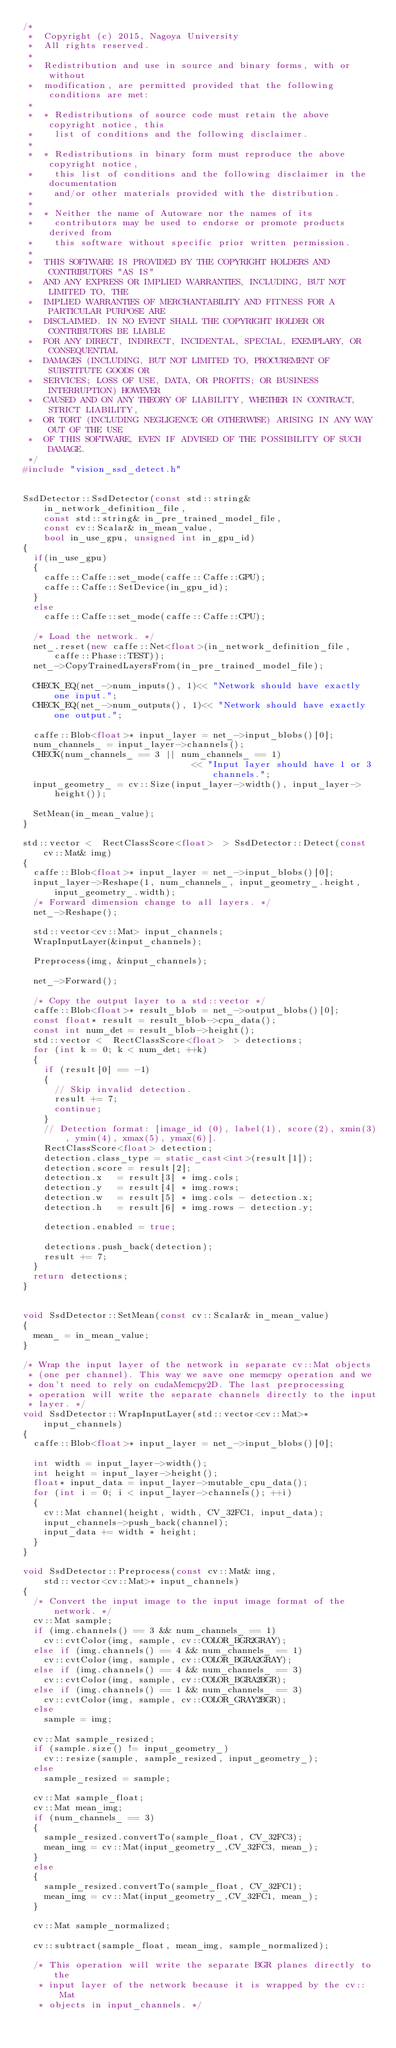<code> <loc_0><loc_0><loc_500><loc_500><_C++_>/*
 *  Copyright (c) 2015, Nagoya University
 *  All rights reserved.
 *
 *  Redistribution and use in source and binary forms, with or without
 *  modification, are permitted provided that the following conditions are met:
 *
 *  * Redistributions of source code must retain the above copyright notice, this
 *    list of conditions and the following disclaimer.
 *
 *  * Redistributions in binary form must reproduce the above copyright notice,
 *    this list of conditions and the following disclaimer in the documentation
 *    and/or other materials provided with the distribution.
 *
 *  * Neither the name of Autoware nor the names of its
 *    contributors may be used to endorse or promote products derived from
 *    this software without specific prior written permission.
 *
 *  THIS SOFTWARE IS PROVIDED BY THE COPYRIGHT HOLDERS AND CONTRIBUTORS "AS IS"
 *  AND ANY EXPRESS OR IMPLIED WARRANTIES, INCLUDING, BUT NOT LIMITED TO, THE
 *  IMPLIED WARRANTIES OF MERCHANTABILITY AND FITNESS FOR A PARTICULAR PURPOSE ARE
 *  DISCLAIMED. IN NO EVENT SHALL THE COPYRIGHT HOLDER OR CONTRIBUTORS BE LIABLE
 *  FOR ANY DIRECT, INDIRECT, INCIDENTAL, SPECIAL, EXEMPLARY, OR CONSEQUENTIAL
 *  DAMAGES (INCLUDING, BUT NOT LIMITED TO, PROCUREMENT OF SUBSTITUTE GOODS OR
 *  SERVICES; LOSS OF USE, DATA, OR PROFITS; OR BUSINESS INTERRUPTION) HOWEVER
 *  CAUSED AND ON ANY THEORY OF LIABILITY, WHETHER IN CONTRACT, STRICT LIABILITY,
 *  OR TORT (INCLUDING NEGLIGENCE OR OTHERWISE) ARISING IN ANY WAY OUT OF THE USE
 *  OF THIS SOFTWARE, EVEN IF ADVISED OF THE POSSIBILITY OF SUCH DAMAGE.
 */
#include "vision_ssd_detect.h"


SsdDetector::SsdDetector(const std::string& in_network_definition_file,
		const std::string& in_pre_trained_model_file,
		const cv::Scalar& in_mean_value,
		bool in_use_gpu, unsigned int in_gpu_id)
{
	if(in_use_gpu)
	{
		caffe::Caffe::set_mode(caffe::Caffe::GPU);
		caffe::Caffe::SetDevice(in_gpu_id);
	}
	else
		caffe::Caffe::set_mode(caffe::Caffe::CPU);

	/* Load the network. */
	net_.reset(new caffe::Net<float>(in_network_definition_file, caffe::Phase::TEST));
	net_->CopyTrainedLayersFrom(in_pre_trained_model_file);

	CHECK_EQ(net_->num_inputs(), 1)<< "Network should have exactly one input.";
	CHECK_EQ(net_->num_outputs(), 1)<< "Network should have exactly one output.";

	caffe::Blob<float>* input_layer = net_->input_blobs()[0];
	num_channels_ = input_layer->channels();
	CHECK(num_channels_ == 3 || num_channels_ == 1)
																<< "Input layer should have 1 or 3 channels.";
	input_geometry_ = cv::Size(input_layer->width(), input_layer->height());

	SetMean(in_mean_value);
}

std::vector <  RectClassScore<float>  > SsdDetector::Detect(const cv::Mat& img)
{
	caffe::Blob<float>* input_layer = net_->input_blobs()[0];
	input_layer->Reshape(1, num_channels_, input_geometry_.height,
			input_geometry_.width);
	/* Forward dimension change to all layers. */
	net_->Reshape();

	std::vector<cv::Mat> input_channels;
	WrapInputLayer(&input_channels);

	Preprocess(img, &input_channels);

	net_->Forward();

	/* Copy the output layer to a std::vector */
	caffe::Blob<float>* result_blob = net_->output_blobs()[0];
	const float* result = result_blob->cpu_data();
	const int num_det = result_blob->height();
	std::vector <  RectClassScore<float>  > detections;
	for (int k = 0; k < num_det; ++k)
	{
		if (result[0] == -1)
		{
			// Skip invalid detection.
			result += 7;
			continue;
		}
		// Detection format: [image_id (0), label(1), score(2), xmin(3), ymin(4), xmax(5), ymax(6)].
		RectClassScore<float> detection;
		detection.class_type = static_cast<int>(result[1]);
		detection.score = result[2];
		detection.x 	= result[3] * img.cols;
		detection.y 	= result[4] * img.rows;
		detection.w 	= result[5] * img.cols - detection.x;
		detection.h 	= result[6] * img.rows - detection.y;

		detection.enabled = true;

		detections.push_back(detection);
		result += 7;
	}
	return detections;
}


void SsdDetector::SetMean(const cv::Scalar& in_mean_value)
{
	mean_ = in_mean_value;
}

/* Wrap the input layer of the network in separate cv::Mat objects
 * (one per channel). This way we save one memcpy operation and we
 * don't need to rely on cudaMemcpy2D. The last preprocessing
 * operation will write the separate channels directly to the input
 * layer. */
void SsdDetector::WrapInputLayer(std::vector<cv::Mat>* input_channels)
{
	caffe::Blob<float>* input_layer = net_->input_blobs()[0];

	int width = input_layer->width();
	int height = input_layer->height();
	float* input_data = input_layer->mutable_cpu_data();
	for (int i = 0; i < input_layer->channels(); ++i)
	{
		cv::Mat channel(height, width, CV_32FC1, input_data);
		input_channels->push_back(channel);
		input_data += width * height;
	}
}

void SsdDetector::Preprocess(const cv::Mat& img,
		std::vector<cv::Mat>* input_channels)
{
	/* Convert the input image to the input image format of the network. */
	cv::Mat sample;
	if (img.channels() == 3 && num_channels_ == 1)
		cv::cvtColor(img, sample, cv::COLOR_BGR2GRAY);
	else if (img.channels() == 4 && num_channels_ == 1)
		cv::cvtColor(img, sample, cv::COLOR_BGRA2GRAY);
	else if (img.channels() == 4 && num_channels_ == 3)
		cv::cvtColor(img, sample, cv::COLOR_BGRA2BGR);
	else if (img.channels() == 1 && num_channels_ == 3)
		cv::cvtColor(img, sample, cv::COLOR_GRAY2BGR);
	else
		sample = img;

	cv::Mat sample_resized;
	if (sample.size() != input_geometry_)
		cv::resize(sample, sample_resized, input_geometry_);
	else
		sample_resized = sample;

	cv::Mat sample_float;
	cv::Mat mean_img;
	if (num_channels_ == 3)
	{
		sample_resized.convertTo(sample_float, CV_32FC3);
		mean_img = cv::Mat(input_geometry_,CV_32FC3, mean_);
	}
	else
	{
		sample_resized.convertTo(sample_float, CV_32FC1);
		mean_img = cv::Mat(input_geometry_,CV_32FC1, mean_);
	}

	cv::Mat sample_normalized;

	cv::subtract(sample_float, mean_img, sample_normalized);

	/* This operation will write the separate BGR planes directly to the
	 * input layer of the network because it is wrapped by the cv::Mat
	 * objects in input_channels. */</code> 